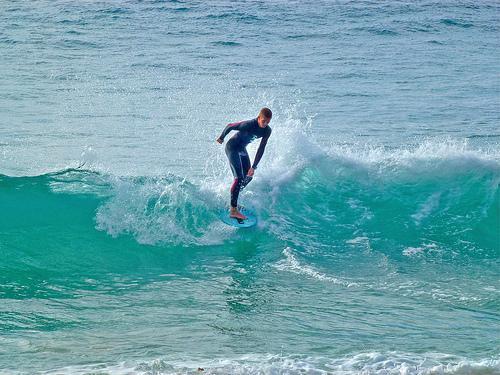How many people are shown?
Give a very brief answer. 1. 